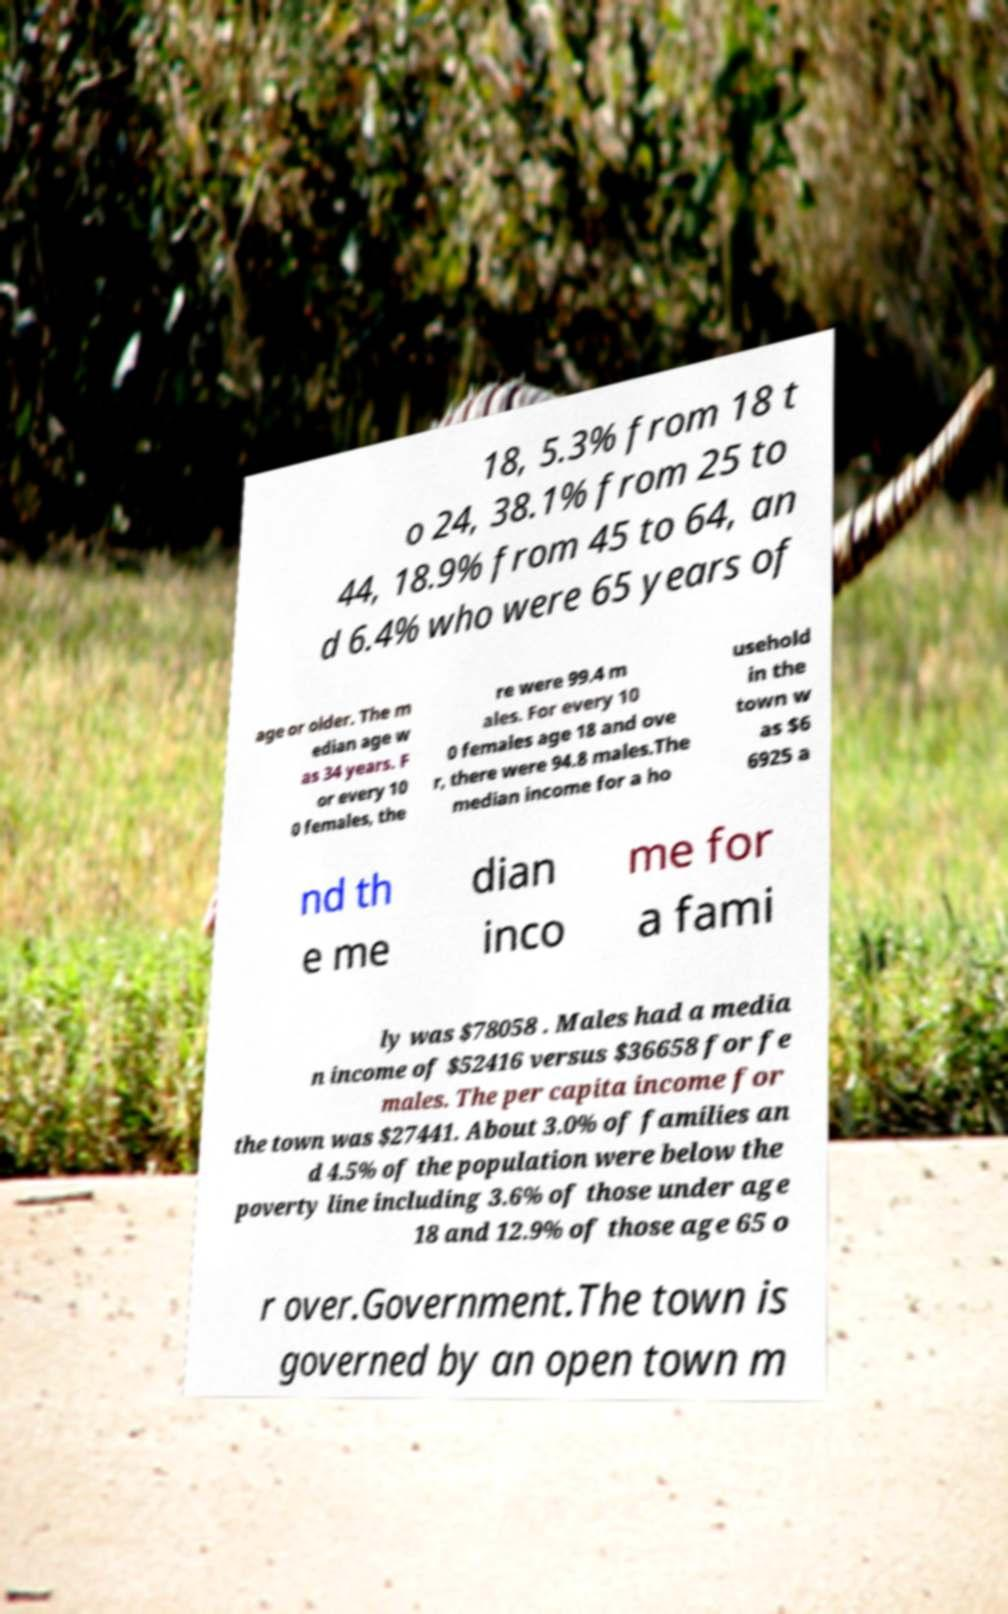Can you accurately transcribe the text from the provided image for me? 18, 5.3% from 18 t o 24, 38.1% from 25 to 44, 18.9% from 45 to 64, an d 6.4% who were 65 years of age or older. The m edian age w as 34 years. F or every 10 0 females, the re were 99.4 m ales. For every 10 0 females age 18 and ove r, there were 94.8 males.The median income for a ho usehold in the town w as $6 6925 a nd th e me dian inco me for a fami ly was $78058 . Males had a media n income of $52416 versus $36658 for fe males. The per capita income for the town was $27441. About 3.0% of families an d 4.5% of the population were below the poverty line including 3.6% of those under age 18 and 12.9% of those age 65 o r over.Government.The town is governed by an open town m 